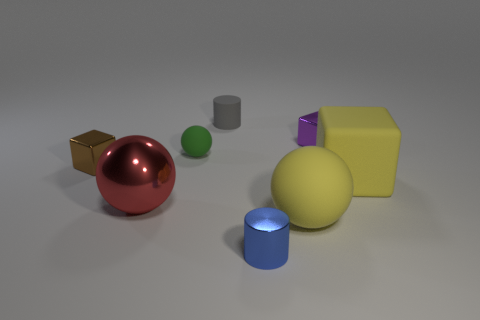Add 2 red blocks. How many objects exist? 10 Subtract all cylinders. How many objects are left? 6 Subtract all cyan matte balls. Subtract all brown shiny cubes. How many objects are left? 7 Add 5 brown shiny blocks. How many brown shiny blocks are left? 6 Add 7 small yellow things. How many small yellow things exist? 7 Subtract 0 gray blocks. How many objects are left? 8 